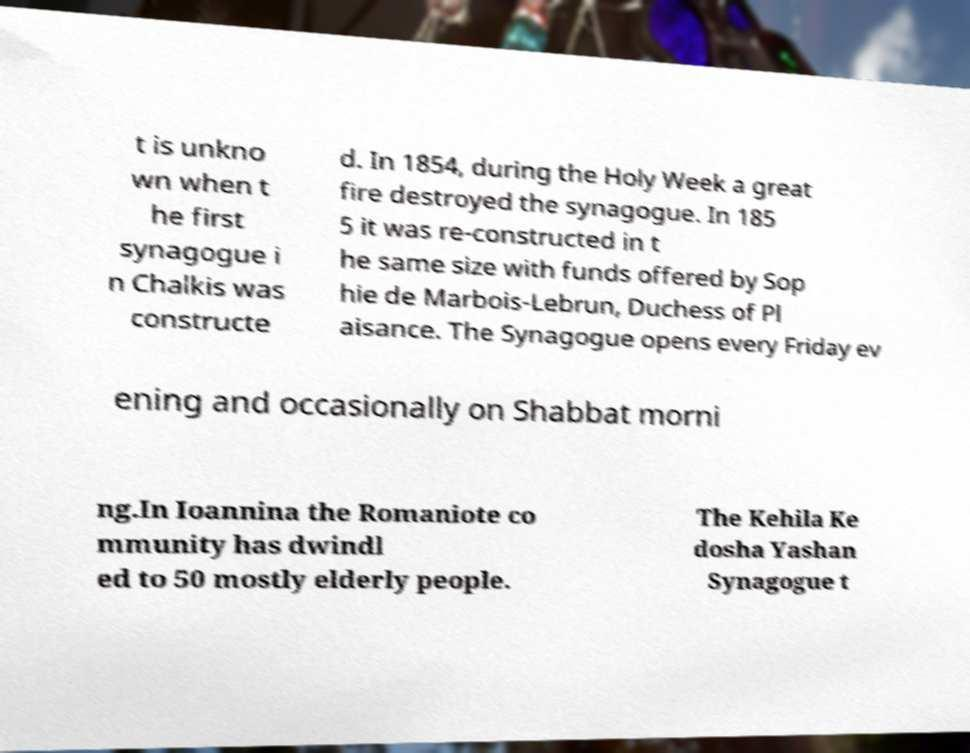Please read and relay the text visible in this image. What does it say? t is unkno wn when t he first synagogue i n Chalkis was constructe d. In 1854, during the Holy Week a great fire destroyed the synagogue. In 185 5 it was re-constructed in t he same size with funds offered by Sop hie de Marbois-Lebrun, Duchess of Pl aisance. The Synagogue opens every Friday ev ening and occasionally on Shabbat morni ng.In Ioannina the Romaniote co mmunity has dwindl ed to 50 mostly elderly people. The Kehila Ke dosha Yashan Synagogue t 